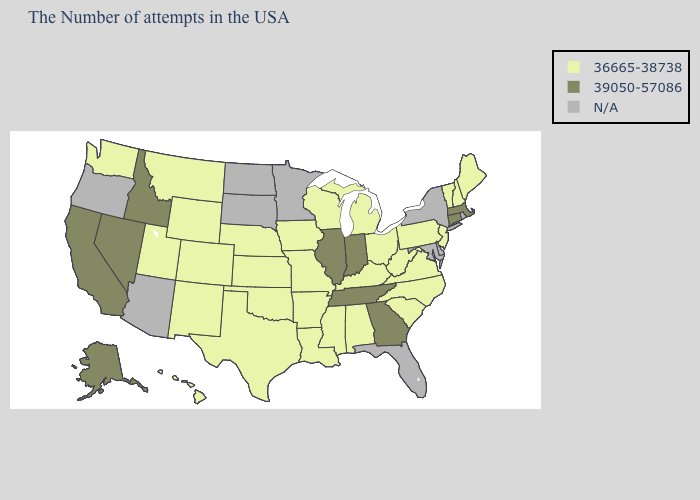What is the lowest value in states that border Oregon?
Concise answer only. 36665-38738. Name the states that have a value in the range 39050-57086?
Quick response, please. Massachusetts, Connecticut, Georgia, Indiana, Tennessee, Illinois, Idaho, Nevada, California, Alaska. What is the value of New Jersey?
Short answer required. 36665-38738. Name the states that have a value in the range 36665-38738?
Keep it brief. Maine, New Hampshire, Vermont, New Jersey, Pennsylvania, Virginia, North Carolina, South Carolina, West Virginia, Ohio, Michigan, Kentucky, Alabama, Wisconsin, Mississippi, Louisiana, Missouri, Arkansas, Iowa, Kansas, Nebraska, Oklahoma, Texas, Wyoming, Colorado, New Mexico, Utah, Montana, Washington, Hawaii. Does Georgia have the highest value in the USA?
Answer briefly. Yes. Does New Hampshire have the highest value in the Northeast?
Be succinct. No. What is the lowest value in states that border Wyoming?
Concise answer only. 36665-38738. Which states have the highest value in the USA?
Write a very short answer. Massachusetts, Connecticut, Georgia, Indiana, Tennessee, Illinois, Idaho, Nevada, California, Alaska. What is the value of Iowa?
Give a very brief answer. 36665-38738. Name the states that have a value in the range 39050-57086?
Give a very brief answer. Massachusetts, Connecticut, Georgia, Indiana, Tennessee, Illinois, Idaho, Nevada, California, Alaska. Does the first symbol in the legend represent the smallest category?
Quick response, please. Yes. Which states hav the highest value in the West?
Quick response, please. Idaho, Nevada, California, Alaska. 